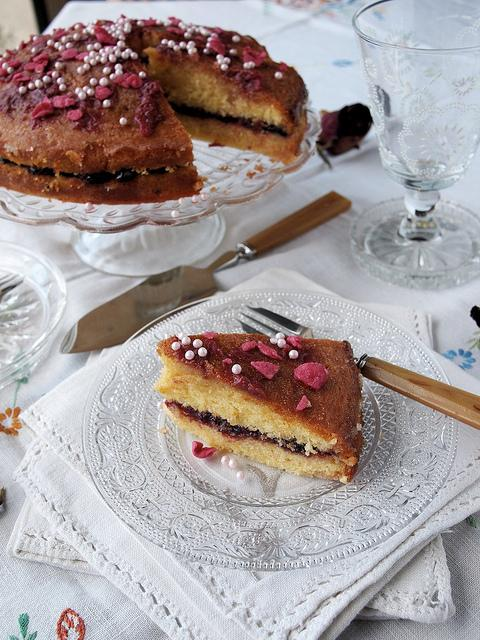What is the filling made of?

Choices:
A) ice cream
B) frosting
C) fruit
D) custard fruit 